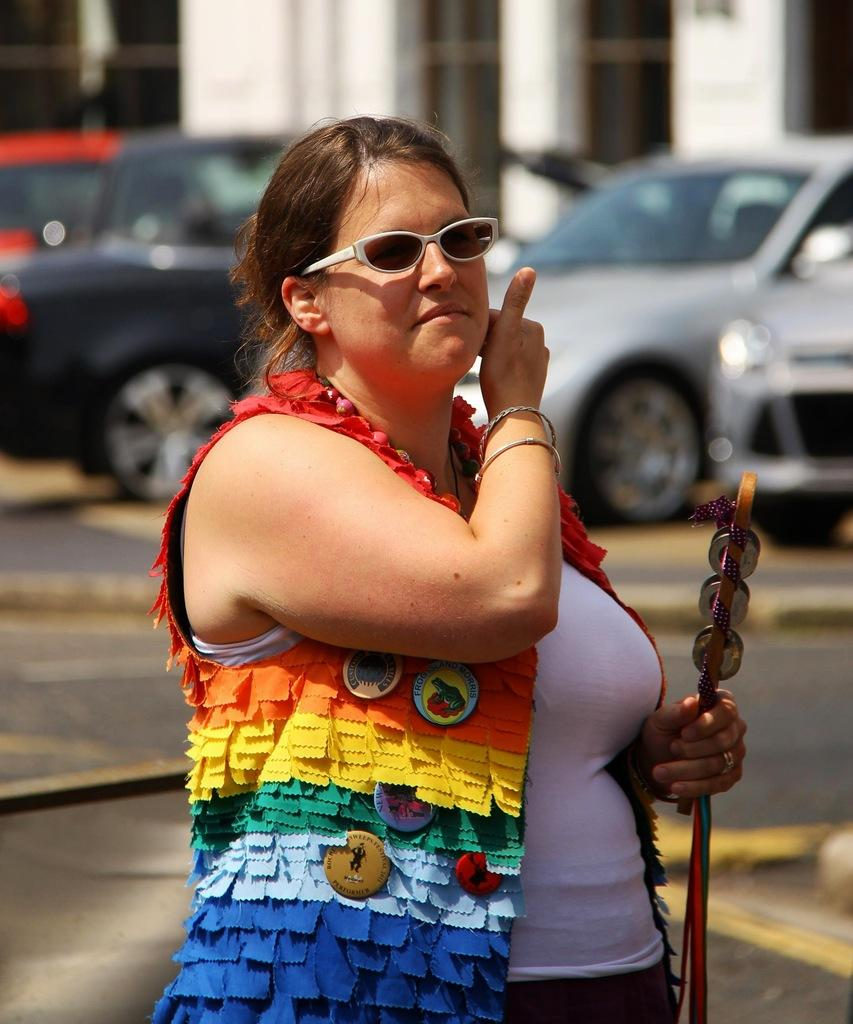Where was the image taken? The image was clicked outside. Who is the main subject in the image? There is a woman in the foreground of the image. What is the woman holding in the image? The woman is holding an object. What is the woman doing in the image? The woman appears to be walking. What can be seen in the background of the image? There is a building and cars in the background of the image. How many chickens are running around the woman in the image? There are no chickens present in the image. What type of rabbit can be seen hopping near the woman in the image? There is no rabbit present in the image. 